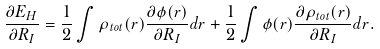<formula> <loc_0><loc_0><loc_500><loc_500>\frac { \partial E _ { H } } { \partial { R _ { I } } } = \frac { 1 } { 2 } \int \rho _ { t o t } ( { r } ) \frac { \partial \phi ( { r } ) } { \partial { R _ { I } } } d { r } + \frac { 1 } { 2 } \int \phi ( { r } ) \frac { \partial \rho _ { t o t } ( { r } ) } { \partial { R _ { I } } } d { r } .</formula> 